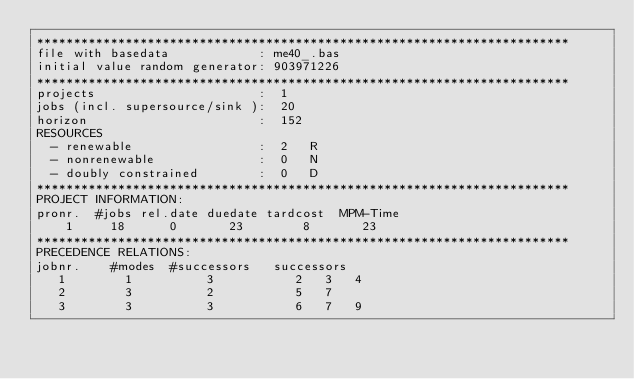Convert code to text. <code><loc_0><loc_0><loc_500><loc_500><_ObjectiveC_>************************************************************************
file with basedata            : me40_.bas
initial value random generator: 903971226
************************************************************************
projects                      :  1
jobs (incl. supersource/sink ):  20
horizon                       :  152
RESOURCES
  - renewable                 :  2   R
  - nonrenewable              :  0   N
  - doubly constrained        :  0   D
************************************************************************
PROJECT INFORMATION:
pronr.  #jobs rel.date duedate tardcost  MPM-Time
    1     18      0       23        8       23
************************************************************************
PRECEDENCE RELATIONS:
jobnr.    #modes  #successors   successors
   1        1          3           2   3   4
   2        3          2           5   7
   3        3          3           6   7   9</code> 